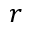<formula> <loc_0><loc_0><loc_500><loc_500>r</formula> 